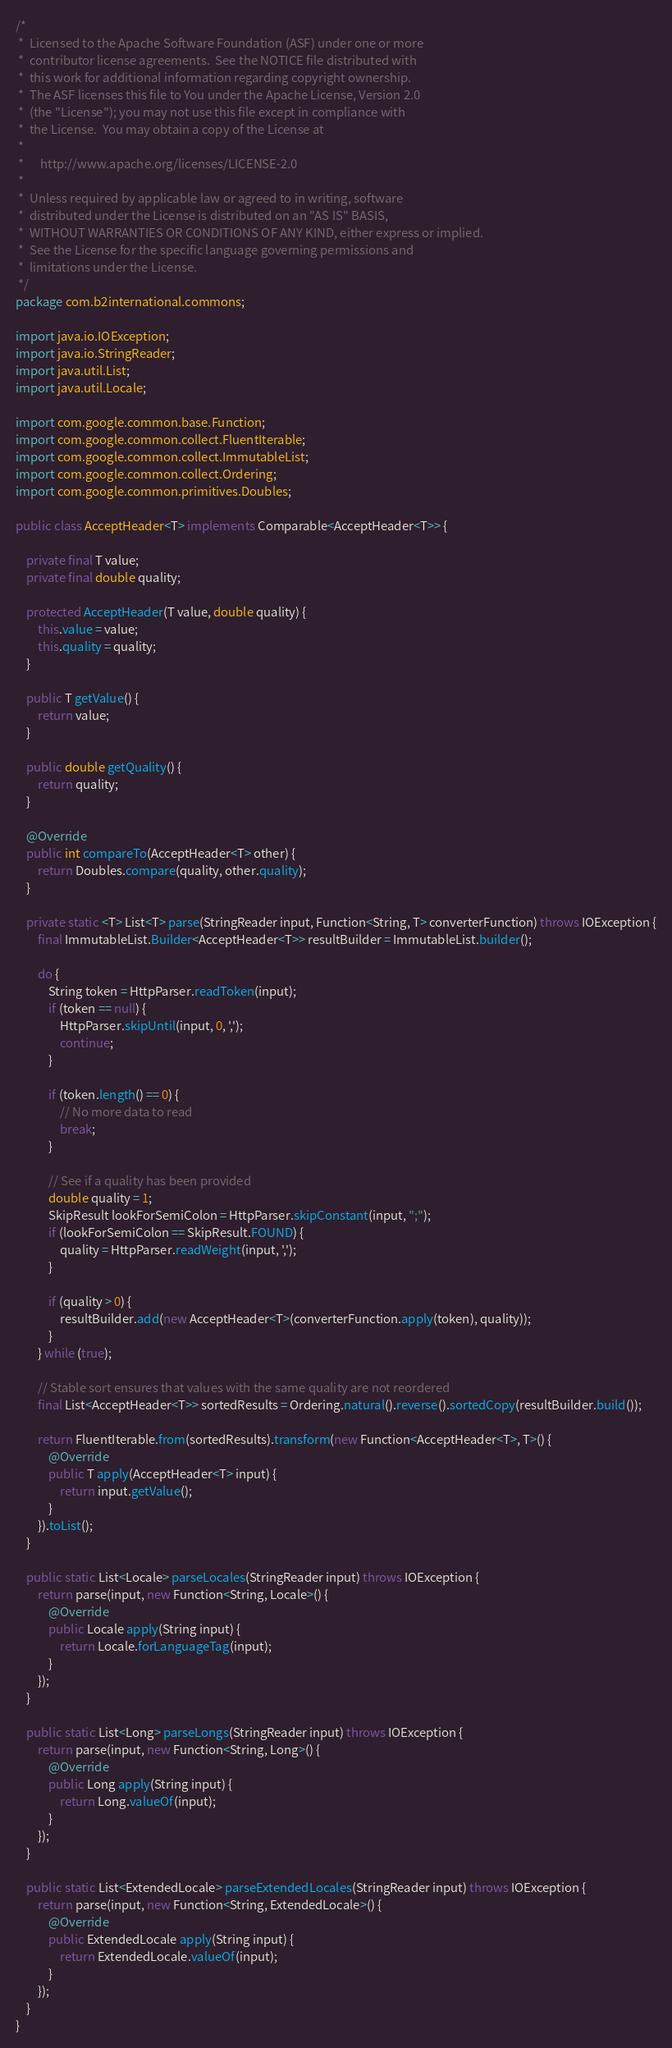<code> <loc_0><loc_0><loc_500><loc_500><_Java_>/*
 *  Licensed to the Apache Software Foundation (ASF) under one or more
 *  contributor license agreements.  See the NOTICE file distributed with
 *  this work for additional information regarding copyright ownership.
 *  The ASF licenses this file to You under the Apache License, Version 2.0
 *  (the "License"); you may not use this file except in compliance with
 *  the License.  You may obtain a copy of the License at
 *
 *      http://www.apache.org/licenses/LICENSE-2.0
 *
 *  Unless required by applicable law or agreed to in writing, software
 *  distributed under the License is distributed on an "AS IS" BASIS,
 *  WITHOUT WARRANTIES OR CONDITIONS OF ANY KIND, either express or implied.
 *  See the License for the specific language governing permissions and
 *  limitations under the License.
 */
package com.b2international.commons;

import java.io.IOException;
import java.io.StringReader;
import java.util.List;
import java.util.Locale;

import com.google.common.base.Function;
import com.google.common.collect.FluentIterable;
import com.google.common.collect.ImmutableList;
import com.google.common.collect.Ordering;
import com.google.common.primitives.Doubles;

public class AcceptHeader<T> implements Comparable<AcceptHeader<T>> {

    private final T value;
    private final double quality;

    protected AcceptHeader(T value, double quality) {
        this.value = value;
        this.quality = quality;
    }

    public T getValue() {
        return value;
    }

    public double getQuality() {
        return quality;
    }
    
	@Override
	public int compareTo(AcceptHeader<T> other) {
		return Doubles.compare(quality, other.quality);
	}

    private static <T> List<T> parse(StringReader input, Function<String, T> converterFunction) throws IOException {
        final ImmutableList.Builder<AcceptHeader<T>> resultBuilder = ImmutableList.builder();

        do {
            String token = HttpParser.readToken(input);
            if (token == null) {
                HttpParser.skipUntil(input, 0, ',');
                continue;
            }

            if (token.length() == 0) {
                // No more data to read
                break;
            }

            // See if a quality has been provided
            double quality = 1;
            SkipResult lookForSemiColon = HttpParser.skipConstant(input, ";");
            if (lookForSemiColon == SkipResult.FOUND) {
                quality = HttpParser.readWeight(input, ',');
            }

            if (quality > 0) {
                resultBuilder.add(new AcceptHeader<T>(converterFunction.apply(token), quality));
            }
        } while (true);

        // Stable sort ensures that values with the same quality are not reordered
        final List<AcceptHeader<T>> sortedResults = Ordering.natural().reverse().sortedCopy(resultBuilder.build());
        
        return FluentIterable.from(sortedResults).transform(new Function<AcceptHeader<T>, T>() {
        	@Override
        	public T apply(AcceptHeader<T> input) {
        		return input.getValue();
        	}
		}).toList();
    }
    
    public static List<Locale> parseLocales(StringReader input) throws IOException {
    	return parse(input, new Function<String, Locale>() {
    		@Override
    		public Locale apply(String input) {
    			return Locale.forLanguageTag(input);
    		}
		});
    }
    
    public static List<Long> parseLongs(StringReader input) throws IOException {
    	return parse(input, new Function<String, Long>() {
    		@Override
    		public Long apply(String input) {
    			return Long.valueOf(input);
    		}
		});
    }
    
    public static List<ExtendedLocale> parseExtendedLocales(StringReader input) throws IOException {
    	return parse(input, new Function<String, ExtendedLocale>() {
    		@Override
    		public ExtendedLocale apply(String input) {
    			return ExtendedLocale.valueOf(input);
    		}
		});
    }
}
</code> 